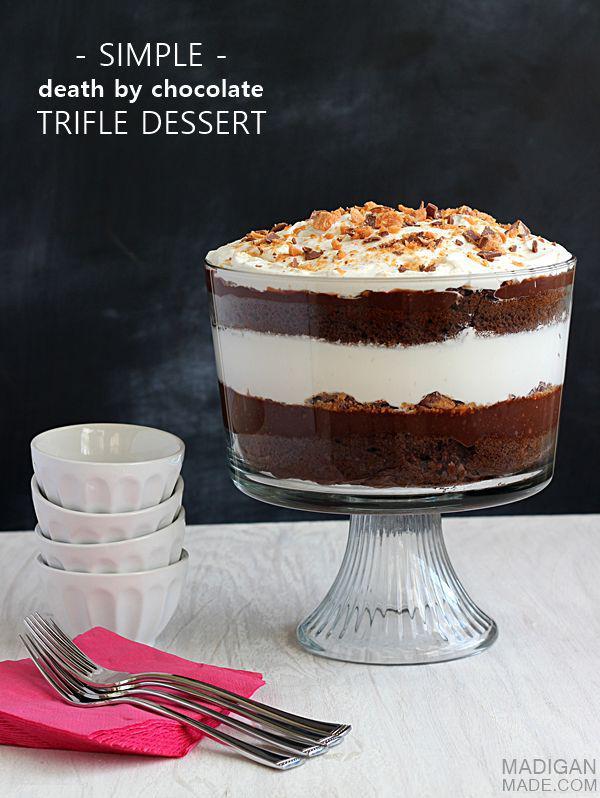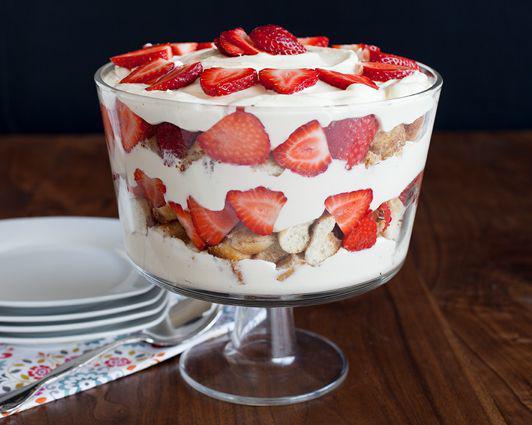The first image is the image on the left, the second image is the image on the right. Given the left and right images, does the statement "Exactly two large trifle desserts in clear footed bowls are shown, one made with chocolate layers and one made with strawberries." hold true? Answer yes or no. Yes. The first image is the image on the left, the second image is the image on the right. Examine the images to the left and right. Is the description "An image shows a layered dessert in a footed glass sitting directly on wood furniture." accurate? Answer yes or no. Yes. 